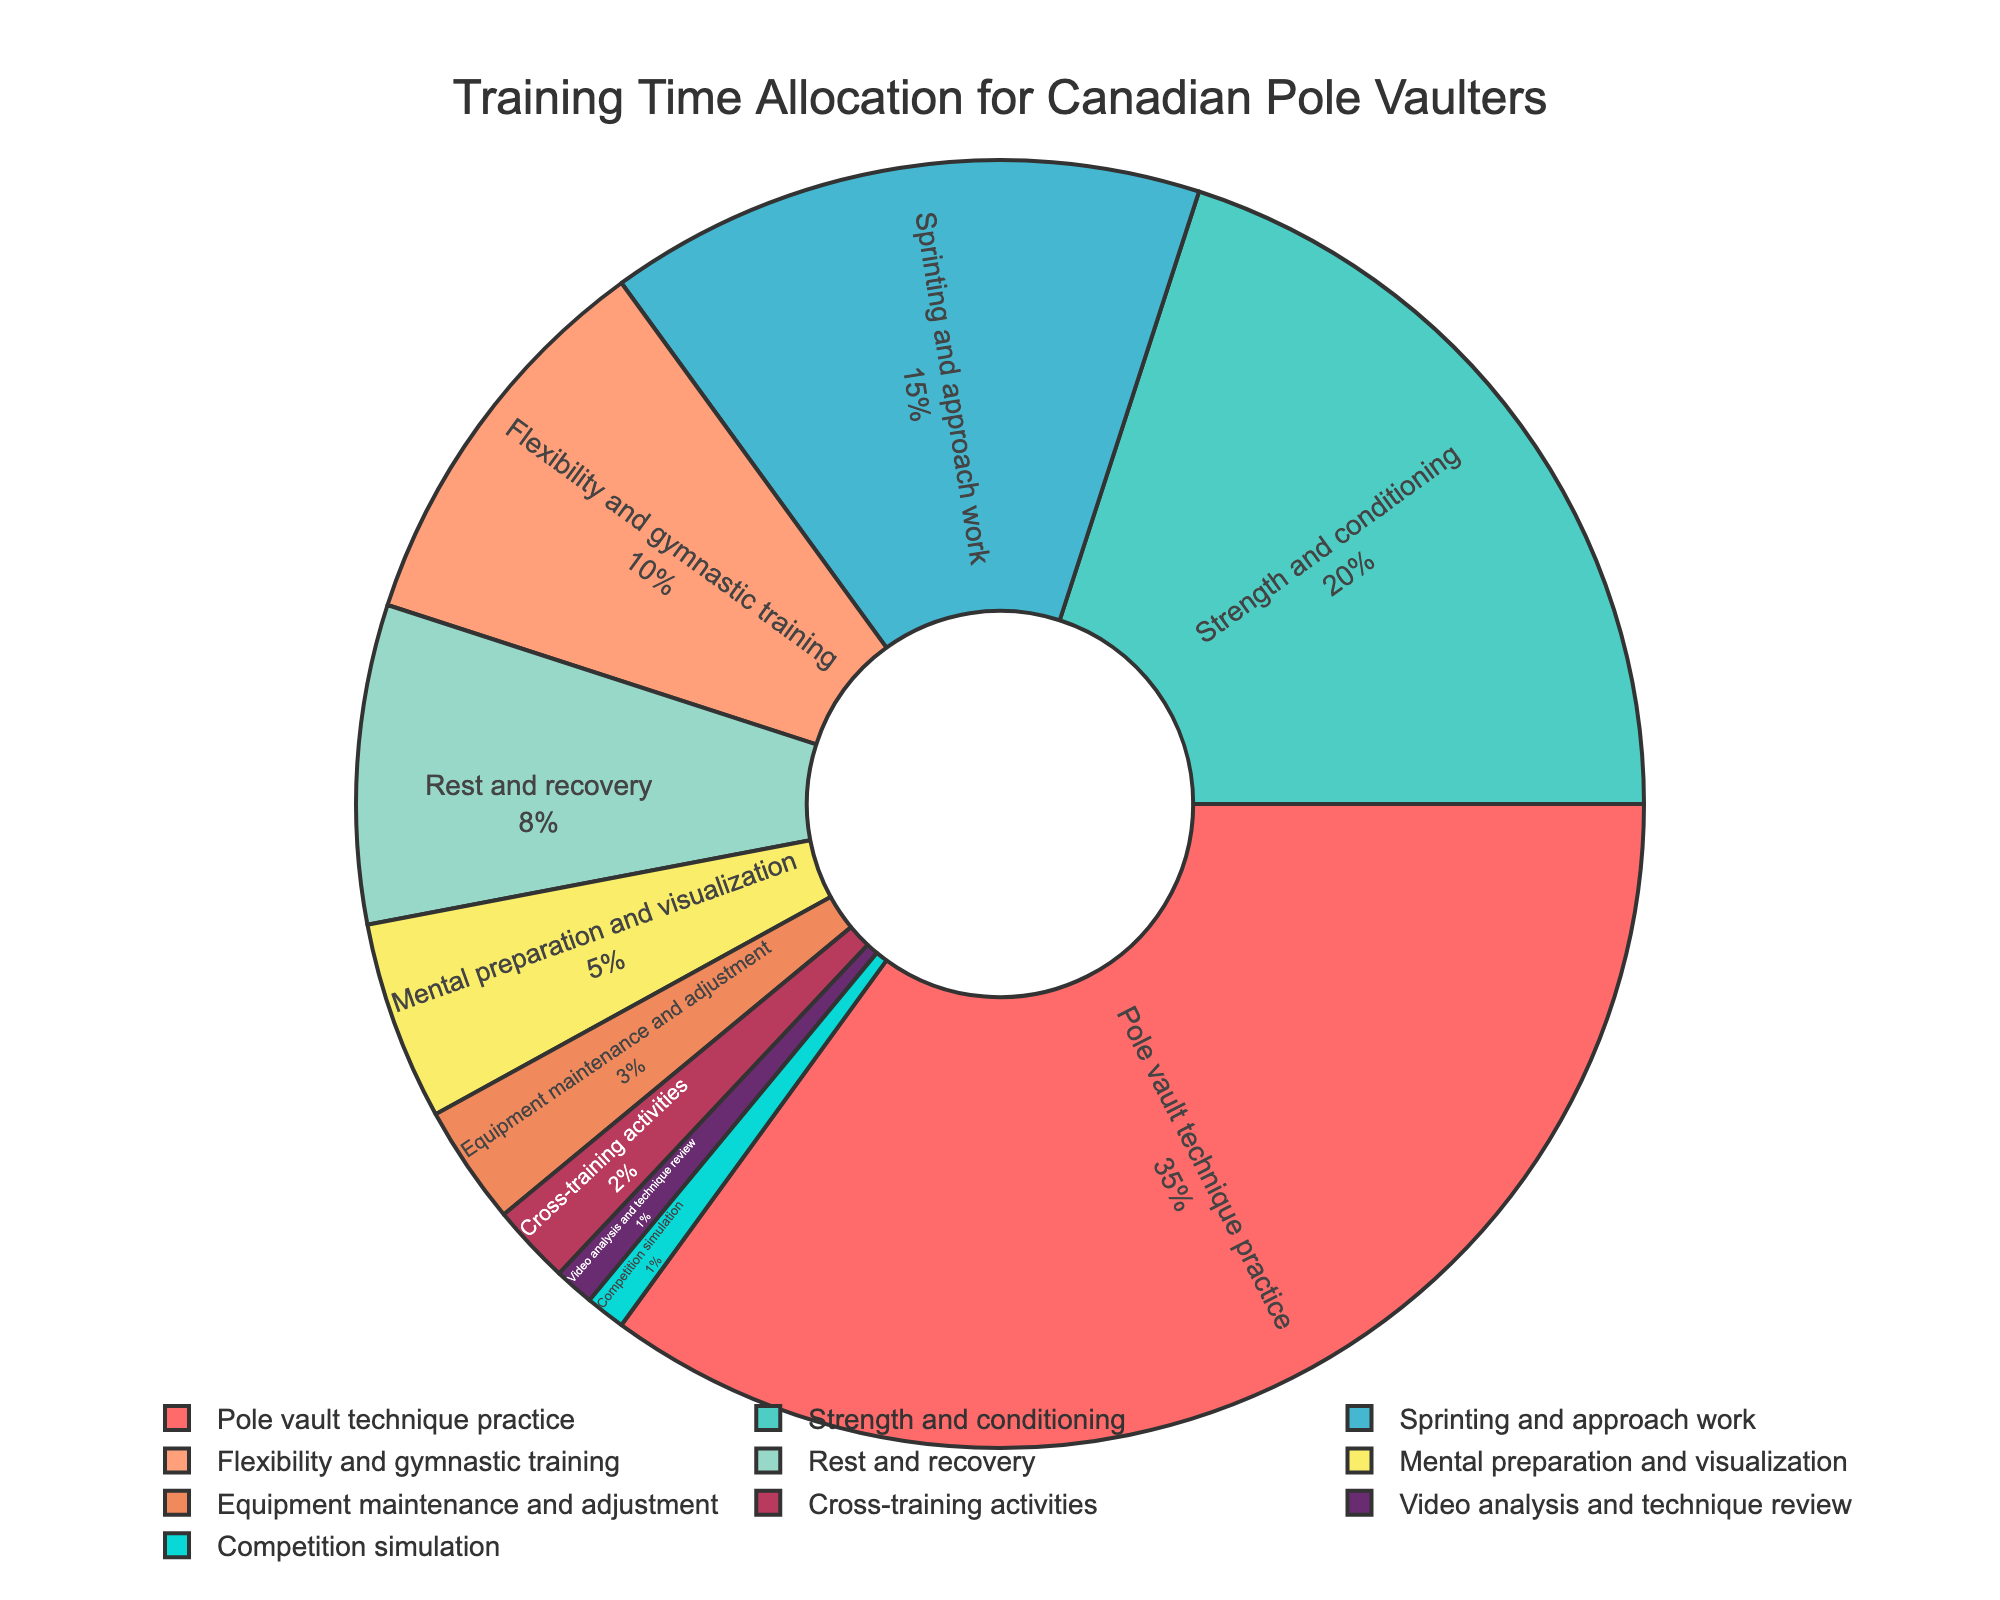What category receives the highest allocation of training time? The largest segment of the pie chart represents the category 'Pole vault technique practice'. From the data, this category has the highest percentage allocation.
Answer: Pole vault technique practice Which two categories combined make up the same percentage as 'Strength and conditioning'? The 'Strength and conditioning' category is 20%. Combining 'Sprinting and approach work' (15%) and 'Flexibility and gymnastic training' (10%) results in 25%, which is close but higher. However, combining 'Flexibility and gymnastic training' (10%) and 'Rest and recovery' (8%) sums to 18%, which is the closest to 20%.
Answer: Flexibility and gymnastic training, and Rest and recovery What is the percentage difference between 'Strength and conditioning' and 'Sprinting and approach work'? 'Strength and conditioning' is 20%, and 'Sprinting and approach work' is 15%. The difference is 20% - 15% = 5%.
Answer: 5% If 'Mental preparation and visualization' was doubled, what would its new percentage be, and how would it compare to 'Pole vault technique practice'? The original percentage for 'Mental preparation and visualization' is 5%. Doubling it would give 5% * 2 = 10%. Compared to 'Pole vault technique practice' at 35%, 10% is still less than 35%.
Answer: 10%, still less How much more training time is allocated to 'Strength and conditioning' than to 'Rest and recovery'? 'Strength and conditioning' is 20%, and 'Rest and recovery' is 8%. The difference is 20% - 8% = 12%.
Answer: 12% If you were to look for categories occupying less than 5% of the training time, which would they be? From the data, the categories with less than 5% are 'Equipment maintenance and adjustment', 'Cross-training activities', 'Video analysis and technique review', and 'Competition simulation'.
Answer: Equipment maintenance and adjustment, Cross-training activities, Video analysis and technique review, Competition simulation What visual characteristics help identify 'Mental preparation and visualization' in the pie chart? 'Mental preparation and visualization' is identified through its smaller size relative to other segments and is located near other small segments. It is the one labeled with 5%.
Answer: Smaller size, labeled 5% 